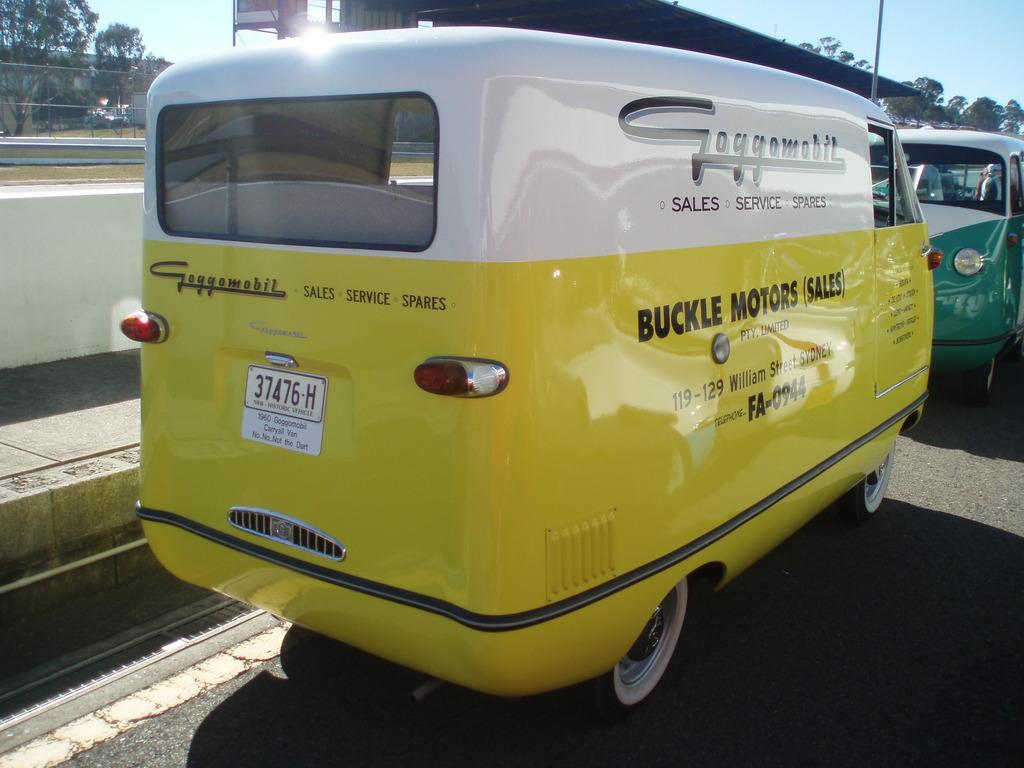What can be seen on the road in the image? There are vehicles on the road in the image. What recreational area is visible in the image? There is a playground in the image. What type of vegetation is present in the image? There are trees in the image. What type of structure can be seen in the image? There is a building in the image. What type of cast is visible on the playground equipment in the image? There is no cast present on the playground equipment in the image. What drug is being administered to the trees in the image? There is no drug being administered to the trees in the image; they are natural vegetation. 